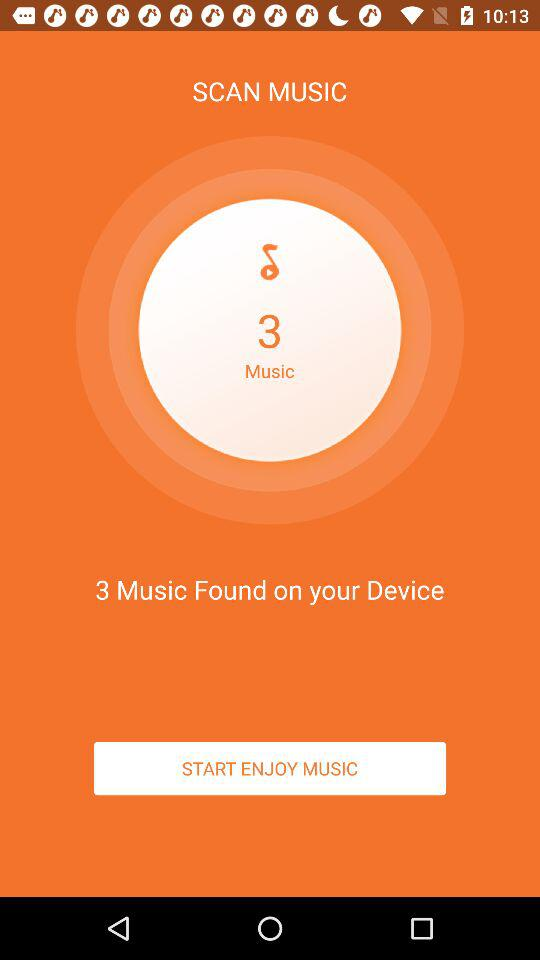How long does it take to scan the music?
When the provided information is insufficient, respond with <no answer>. <no answer> 